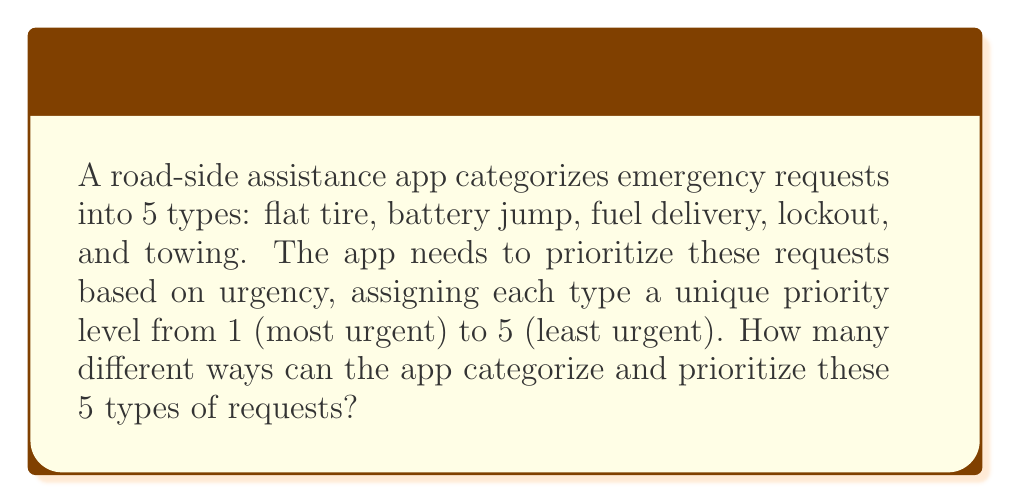Help me with this question. Let's approach this step-by-step:

1) We have 5 different types of requests, and we need to assign each of them a unique priority level from 1 to 5.

2) This scenario is equivalent to arranging 5 distinct objects (the request types) in a line (the priority order).

3) In combinatorics, this is a permutation problem. We are essentially finding the number of permutations of 5 distinct objects.

4) The formula for permutations of n distinct objects is:

   $$P(n) = n!$$

   Where $n!$ represents the factorial of $n$.

5) In this case, $n = 5$, so we need to calculate $5!$:

   $$5! = 5 \times 4 \times 3 \times 2 \times 1 = 120$$

6) Therefore, there are 120 different ways to categorize and prioritize the 5 types of roadside assistance requests.

This result means that the app developer has 120 possible configurations to consider when designing the prioritization system for the road-side assistance app.
Answer: 120 